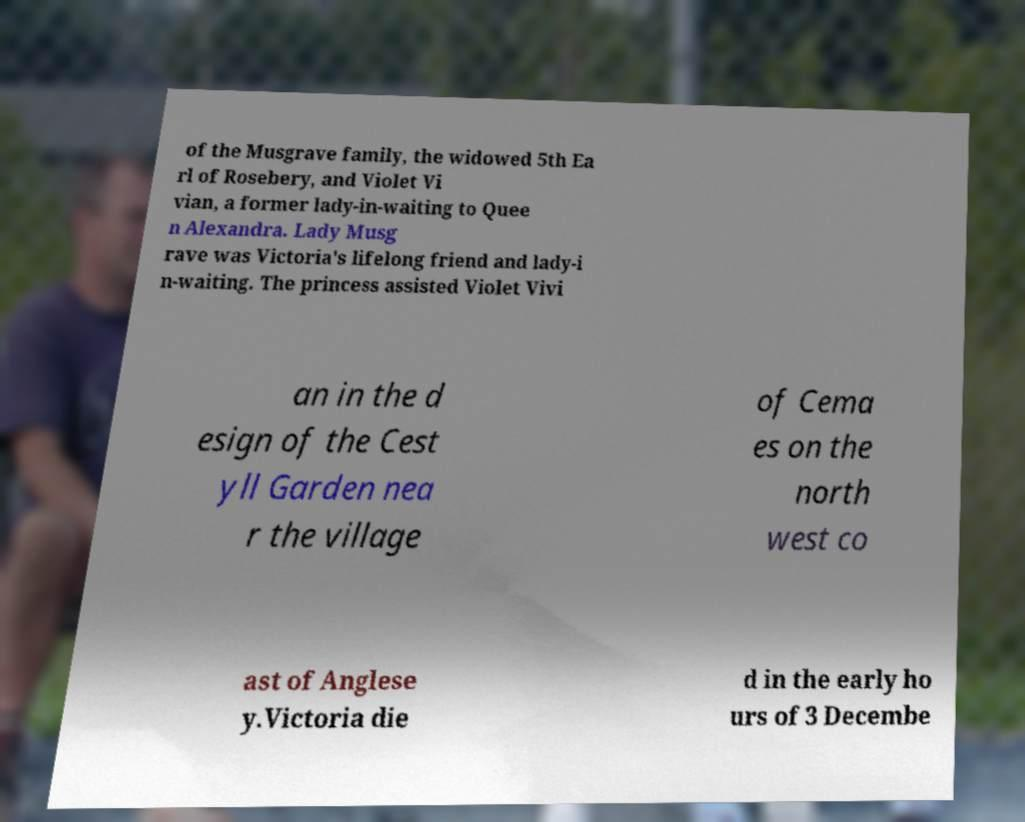Please read and relay the text visible in this image. What does it say? of the Musgrave family, the widowed 5th Ea rl of Rosebery, and Violet Vi vian, a former lady-in-waiting to Quee n Alexandra. Lady Musg rave was Victoria's lifelong friend and lady-i n-waiting. The princess assisted Violet Vivi an in the d esign of the Cest yll Garden nea r the village of Cema es on the north west co ast of Anglese y.Victoria die d in the early ho urs of 3 Decembe 